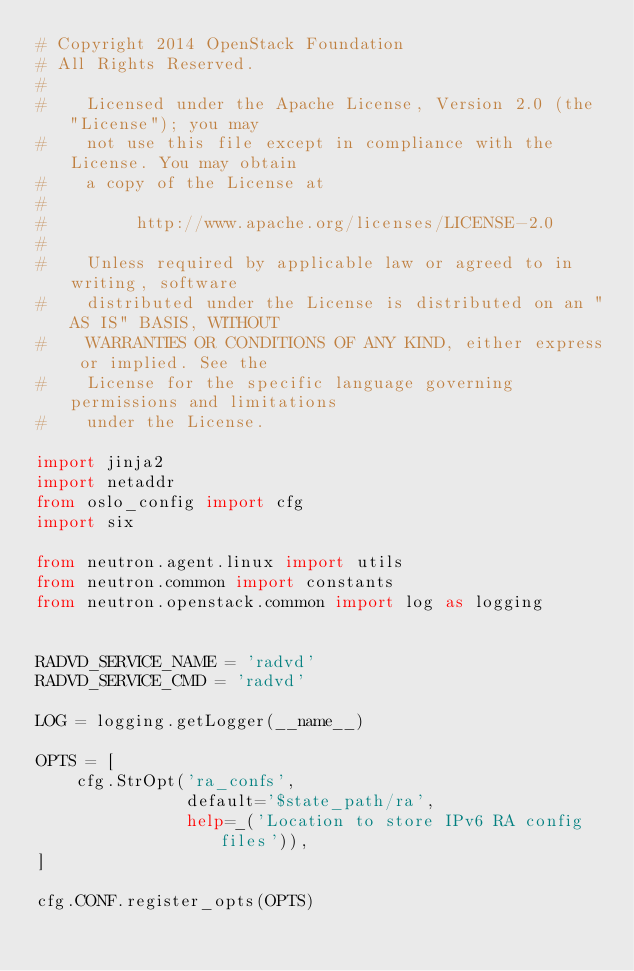<code> <loc_0><loc_0><loc_500><loc_500><_Python_># Copyright 2014 OpenStack Foundation
# All Rights Reserved.
#
#    Licensed under the Apache License, Version 2.0 (the "License"); you may
#    not use this file except in compliance with the License. You may obtain
#    a copy of the License at
#
#         http://www.apache.org/licenses/LICENSE-2.0
#
#    Unless required by applicable law or agreed to in writing, software
#    distributed under the License is distributed on an "AS IS" BASIS, WITHOUT
#    WARRANTIES OR CONDITIONS OF ANY KIND, either express or implied. See the
#    License for the specific language governing permissions and limitations
#    under the License.

import jinja2
import netaddr
from oslo_config import cfg
import six

from neutron.agent.linux import utils
from neutron.common import constants
from neutron.openstack.common import log as logging


RADVD_SERVICE_NAME = 'radvd'
RADVD_SERVICE_CMD = 'radvd'

LOG = logging.getLogger(__name__)

OPTS = [
    cfg.StrOpt('ra_confs',
               default='$state_path/ra',
               help=_('Location to store IPv6 RA config files')),
]

cfg.CONF.register_opts(OPTS)
</code> 